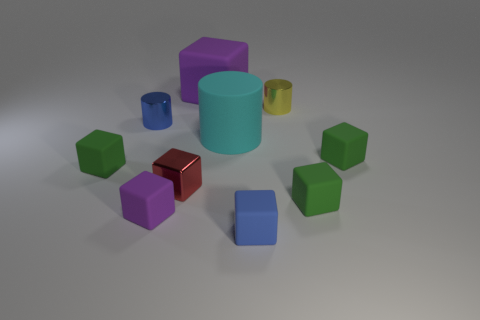There is another large thing that is the same shape as the blue rubber thing; what is it made of?
Provide a short and direct response. Rubber. The big rubber cylinder has what color?
Ensure brevity in your answer.  Cyan. What color is the small matte object that is behind the green block that is on the left side of the red thing?
Ensure brevity in your answer.  Green. Do the matte cylinder and the small cylinder left of the large purple matte object have the same color?
Your answer should be very brief. No. What number of tiny yellow metal things are on the left side of the rubber cube that is behind the shiny cylinder that is on the left side of the yellow thing?
Ensure brevity in your answer.  0. Are there any tiny blue matte objects in front of the yellow metal cylinder?
Your response must be concise. Yes. Is there anything else that is the same color as the big rubber block?
Keep it short and to the point. Yes. What number of balls are small green matte objects or cyan rubber objects?
Make the answer very short. 0. How many matte cubes are in front of the matte cylinder and left of the small blue rubber thing?
Ensure brevity in your answer.  2. Is the number of yellow shiny cylinders behind the metal block the same as the number of tiny blue metallic cylinders to the right of the tiny yellow cylinder?
Offer a very short reply. No. 